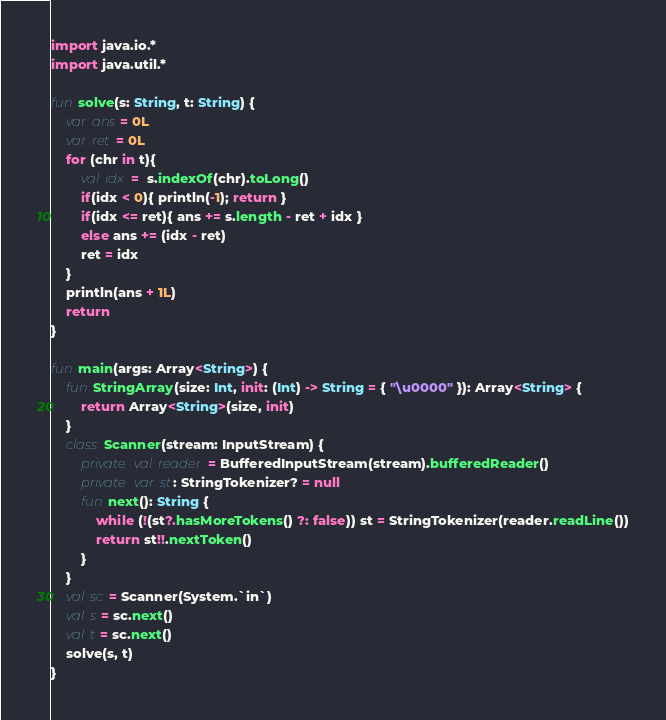Convert code to text. <code><loc_0><loc_0><loc_500><loc_500><_Kotlin_>import java.io.*
import java.util.*

fun solve(s: String, t: String) {
    var ans = 0L
    var ret = 0L
    for (chr in t){
        val idx =  s.indexOf(chr).toLong()
        if(idx < 0){ println(-1); return }
        if(idx <= ret){ ans += s.length - ret + idx }
        else ans += (idx - ret)
        ret = idx
    }
    println(ans + 1L)
    return
}

fun main(args: Array<String>) {
    fun StringArray(size: Int, init: (Int) -> String = { "\u0000" }): Array<String> {
        return Array<String>(size, init)
    }
    class Scanner(stream: InputStream) {
        private val reader = BufferedInputStream(stream).bufferedReader()
        private var st: StringTokenizer? = null
        fun next(): String {
            while (!(st?.hasMoreTokens() ?: false)) st = StringTokenizer(reader.readLine())
            return st!!.nextToken()
        }
    }
    val sc = Scanner(System.`in`)
    val s = sc.next()
    val t = sc.next()
    solve(s, t)
}
</code> 